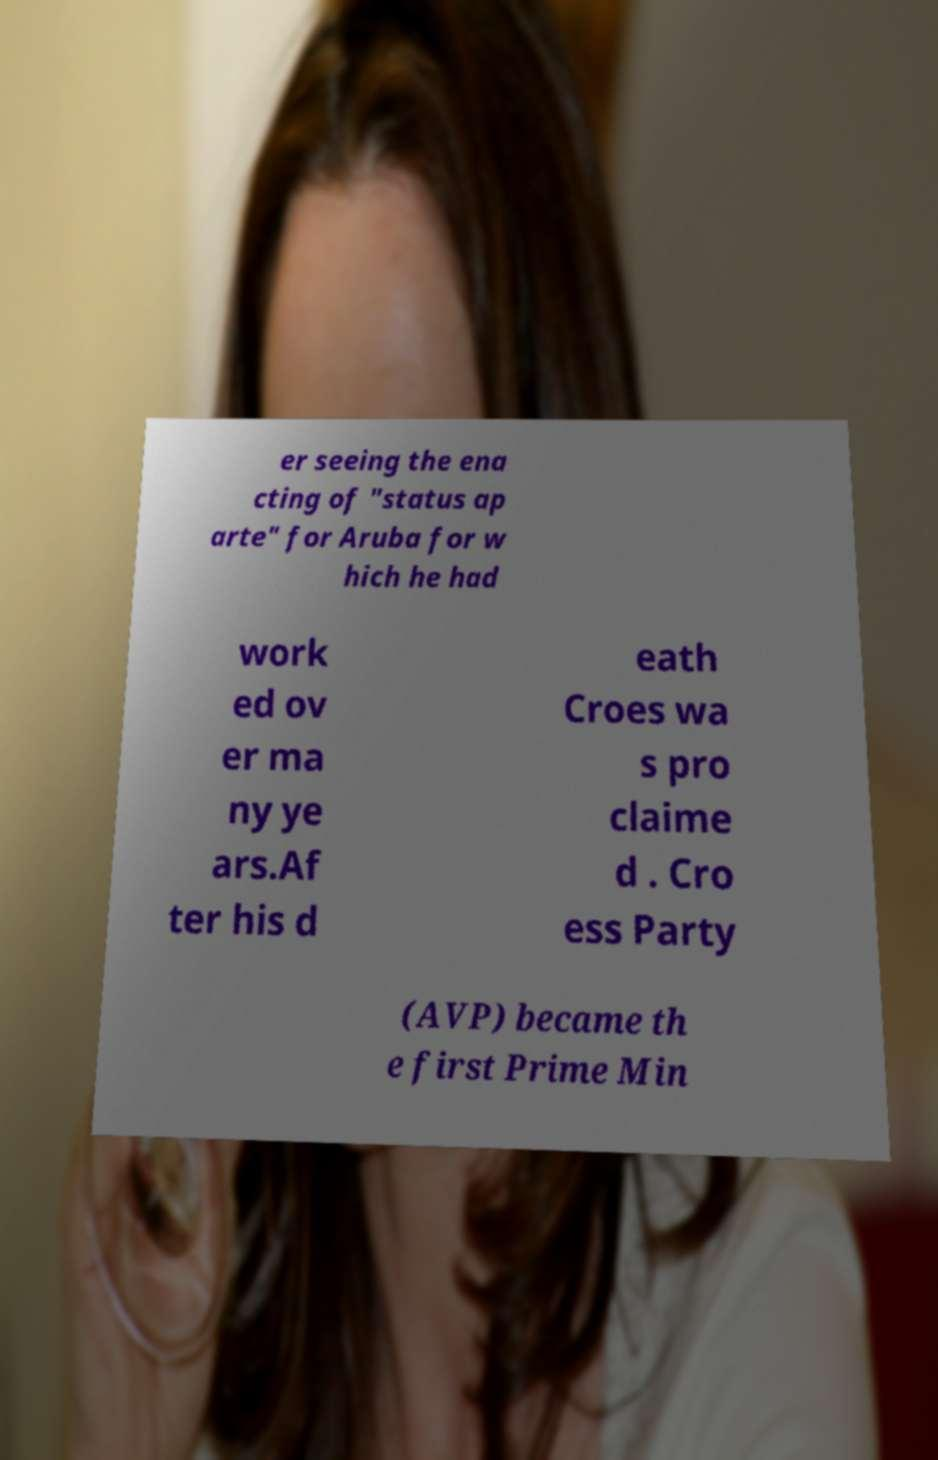Please identify and transcribe the text found in this image. er seeing the ena cting of "status ap arte" for Aruba for w hich he had work ed ov er ma ny ye ars.Af ter his d eath Croes wa s pro claime d . Cro ess Party (AVP) became th e first Prime Min 